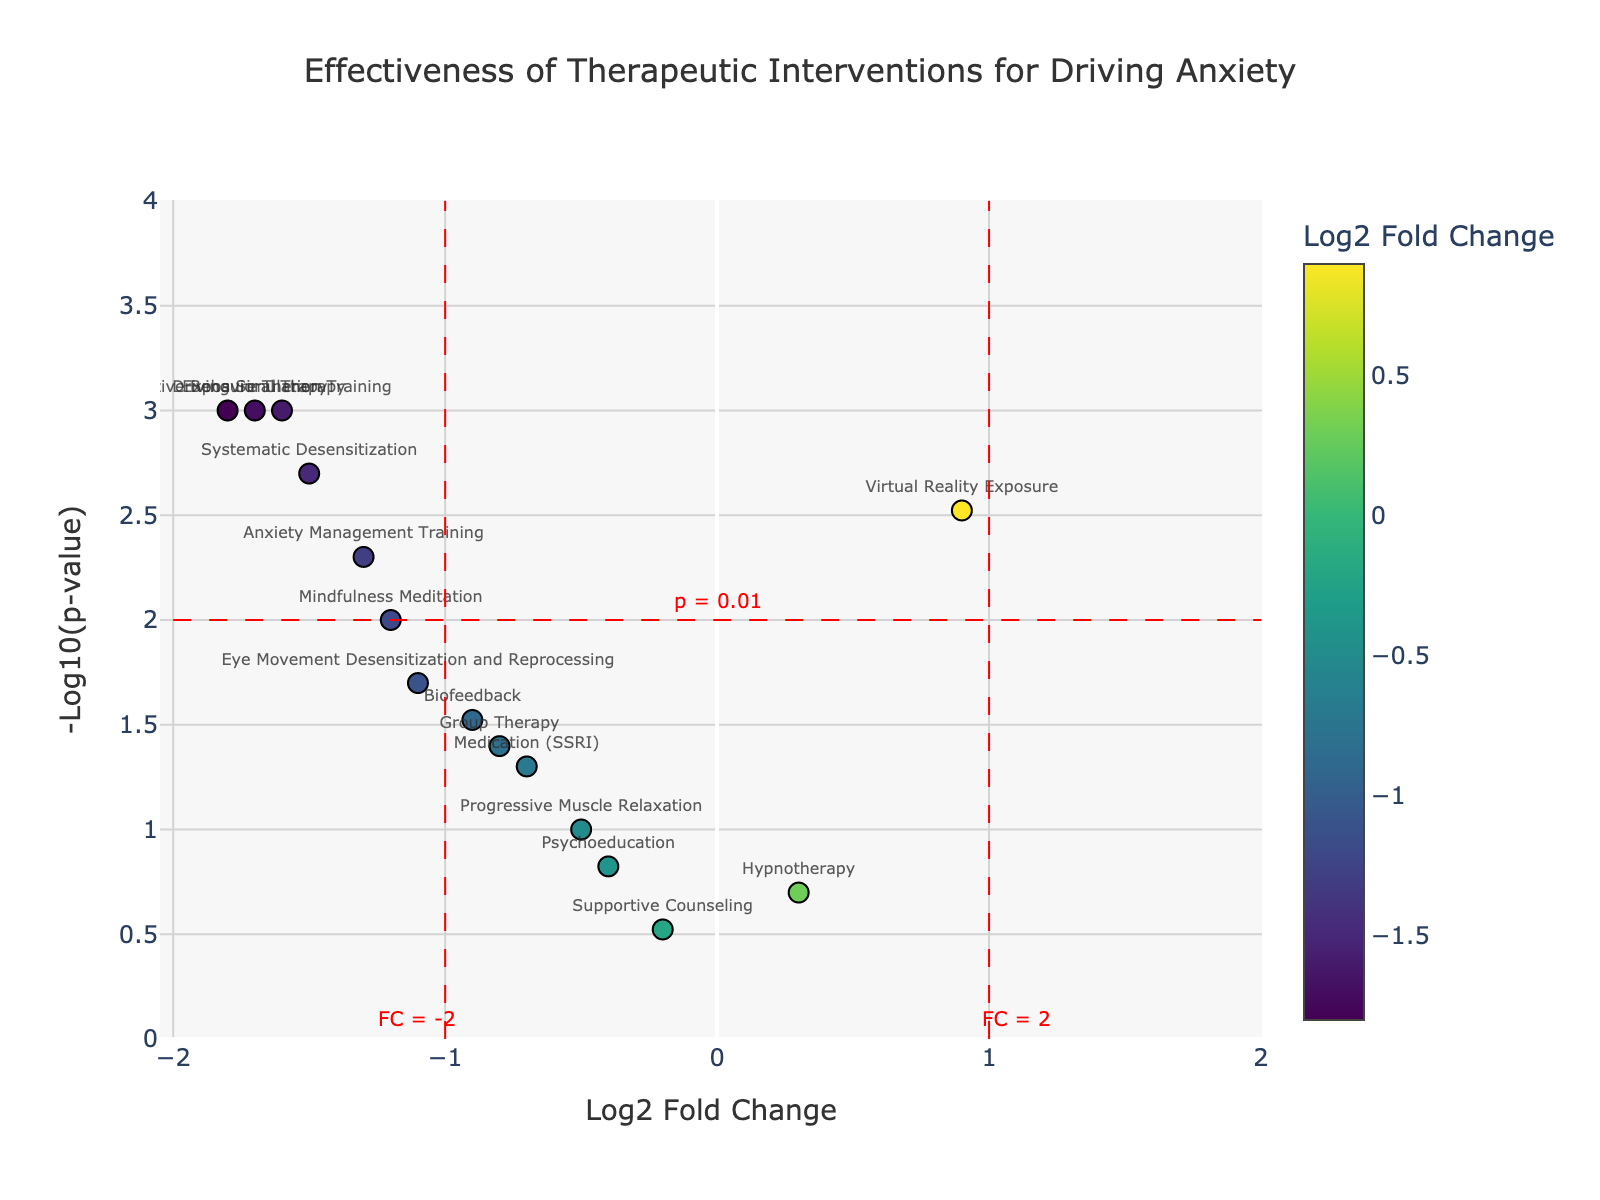What's the title of the figure? The title is displayed at the top of the figure in a large font size and is meant to provide an overview of what the plot represents.
Answer: Effectiveness of Therapeutic Interventions for Driving Anxiety What does the x-axis represent? The x-axis title is visible at the bottom of the plot and explains what the horizontal position of each data point means.
Answer: Log2 Fold Change What does the y-axis represent? The y-axis title is visible on the left-hand side of the plot and indicates what the vertical position of each data point means.
Answer: -Log10(p-value) Which intervention has the highest -Log10(p-value)? By looking at the vertical position of the markers, the one that reaches the highest point on the y-axis indicates the maximum -Log10(p-value).
Answer: Cognitive Behavioral Therapy Is there any intervention with a positive Log2 Fold Change and a -Log10(p-value) greater than 2? By analyzing the plot, focus on the data points that are positioned to the right of zero on the x-axis and above the y=2 line.
Answer: No How many interventions have a -Log10(p-value) greater than 2? Count the number of data points above the horizontal line y=2.
Answer: 4 Which intervention has the lowest Log2 fold change? Identify the data point that is farthest to the left on the x-axis.
Answer: Cognitive Behavioral Therapy Which interventions fall within the region specified by Log2 Fold Change between -1 and 1 and -Log10(p-value) less than 2? Look at the data points within the central region defined by vertical lines at x=-1 and x=1 and below the horizontal line y=2.
Answer: Hypnotherapy, Psychoeducation, Progressive Muscle Relaxation, Supportive Counseling Compare Cognitive Behavioral Therapy and Exposure Therapy in terms of their p-value. Which has a smaller p-value? Convert their -Log10(p-value) back to p-value to compare. Cognitive Behavioral Therapy has -Log10(p-value) of 3, meaning p-value = 10^-3; Exposure Therapy has -Log10(p-value) also of 3.
Answer: They have the same p-value What can you infer about interventions with a negative Log2 Fold Change? Based on the x-axis, a negative Log2 Fold Change suggests a decrease in effectiveness. By positioning, these interventions are less effective against driving anxiety.
Answer: Less effective Among the interventions, which one shows the least statistical significance (highest p-value)? Identify the data point that is the lowest on the y-axis (smallest -Log10(p-value)), as this indicates the highest p-value.
Answer: Supportive Counseling 